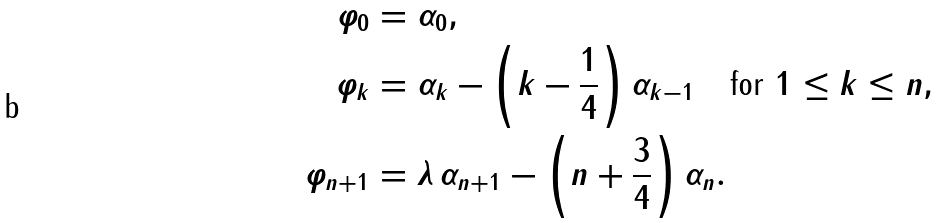<formula> <loc_0><loc_0><loc_500><loc_500>\varphi _ { 0 } & = \alpha _ { 0 } , \\ \varphi _ { k } & = \alpha _ { k } - \left ( k - \frac { 1 } { 4 } \right ) \alpha _ { k - 1 } \quad \text {for } 1 \leq k \leq n , \\ \varphi _ { n + 1 } & = \lambda \, \alpha _ { n + 1 } - \left ( n + \frac { 3 } { 4 } \right ) \alpha _ { n } .</formula> 